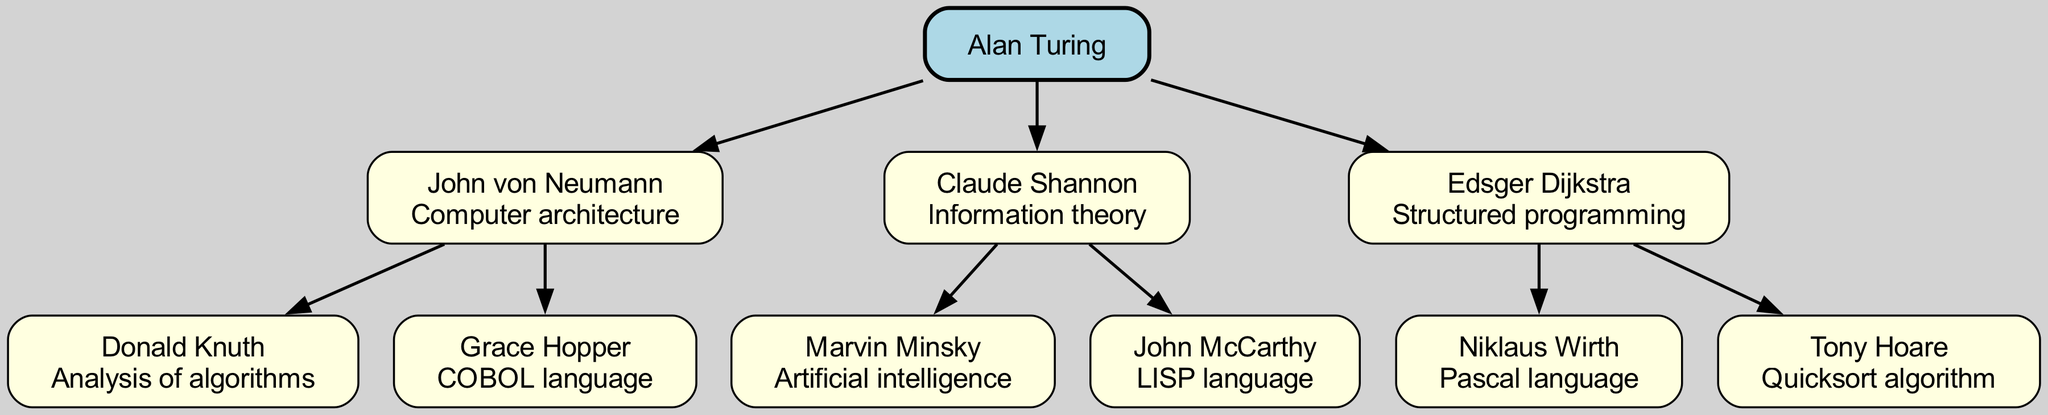What is Alan Turing's contribution? The diagram shows that Alan Turing's contribution is foundational to the field of computer science, although the specific contribution isn't labeled directly; we can rely on general knowledge that he is known for concepts such as the Turing machine and contributions to algorithms and cryptography. However, for this question, we're focusing on the visual representation presented.
Answer: Foundational concepts Who are the children of John von Neumann? The diagram lists John von Neumann and provides his children. By examining the branches under John von Neumann, we see two direct descendants, Donald Knuth and Grace Hopper, provided with their contributions.
Answer: Donald Knuth and Grace Hopper How many influential computer scientists are listed under Edsger Dijkstra? Looking at the subtree under Edsger Dijkstra, we find two children, which represent other influential computer scientists. These are Niklaus Wirth and Tony Hoare.
Answer: 2 What is the contribution of Marvin Minsky? To answer this, we check the diagram under Claude Shannon, where Marvin Minsky has a noted contribution. The information directly attached to his node indicates his contribution to the field of artificial intelligence.
Answer: Artificial intelligence Which node has the contribution of COBOL language? From the diagram segment related to John von Neumann, we can directly identify that his child node, Grace Hopper, is marked with the contribution of the COBOL language.
Answer: Grace Hopper Which child of Claude Shannon contributed to LISP language? By examining the children listed under Claude Shannon, we can find John McCarthy associated with the contribution of the LISP language. This is clearly labeled in the diagram.
Answer: John McCarthy What is the total number of edges in this family tree? To determine this, we count the connections (edges) connecting the parent nodes to their child nodes. Each parent (Alan Turing, John von Neumann, Claude Shannon, and Edsger Dijkstra) has children, and counting all connections gives us the total. In this tree, the number of edges is 6.
Answer: 6 Which scientist focused on structured programming? Within the diagram, Edsger Dijkstra is directly linked as focusing on structured programming, which is noted by the label connected to his node.
Answer: Edsger Dijkstra Who is the direct parent of Donald Knuth? Tracing the lineage in the diagram, we find that Donald Knuth is a child of John von Neumann. This direct relationship is clearly established in the tree structure.
Answer: John von Neumann 